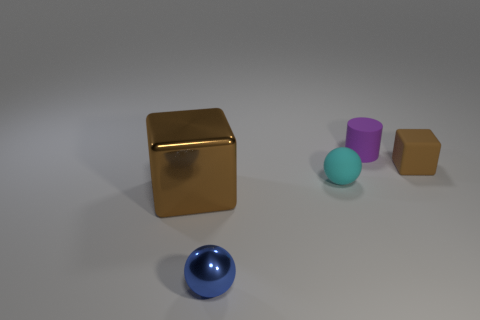Add 3 red rubber spheres. How many objects exist? 8 Subtract all cylinders. How many objects are left? 4 Subtract 0 brown cylinders. How many objects are left? 5 Subtract all large purple metal spheres. Subtract all brown rubber cubes. How many objects are left? 4 Add 1 big brown blocks. How many big brown blocks are left? 2 Add 3 purple things. How many purple things exist? 4 